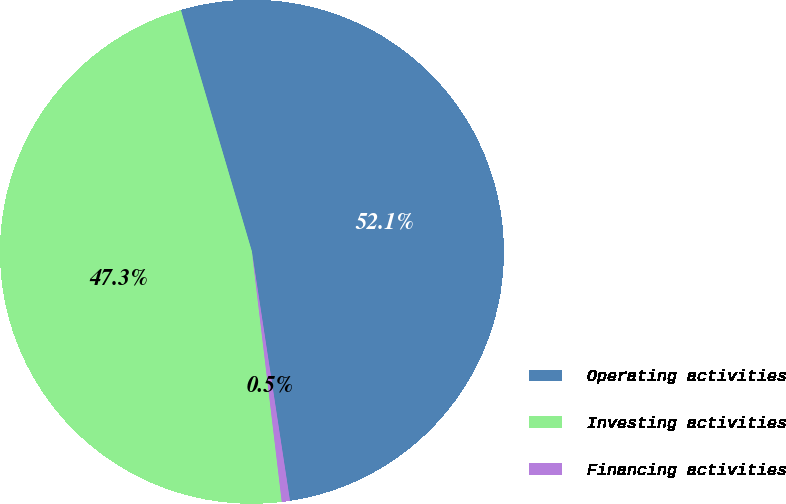<chart> <loc_0><loc_0><loc_500><loc_500><pie_chart><fcel>Operating activities<fcel>Investing activities<fcel>Financing activities<nl><fcel>52.14%<fcel>47.34%<fcel>0.52%<nl></chart> 